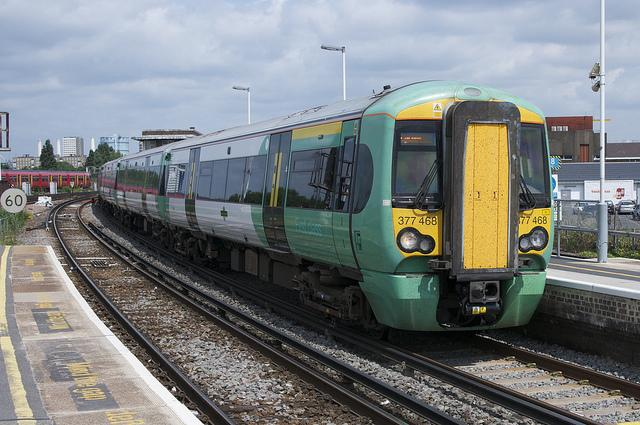What are the black poles on the front train window?

Choices:
A) wipers
B) antennae
C) handles
D) bumpers wipers 